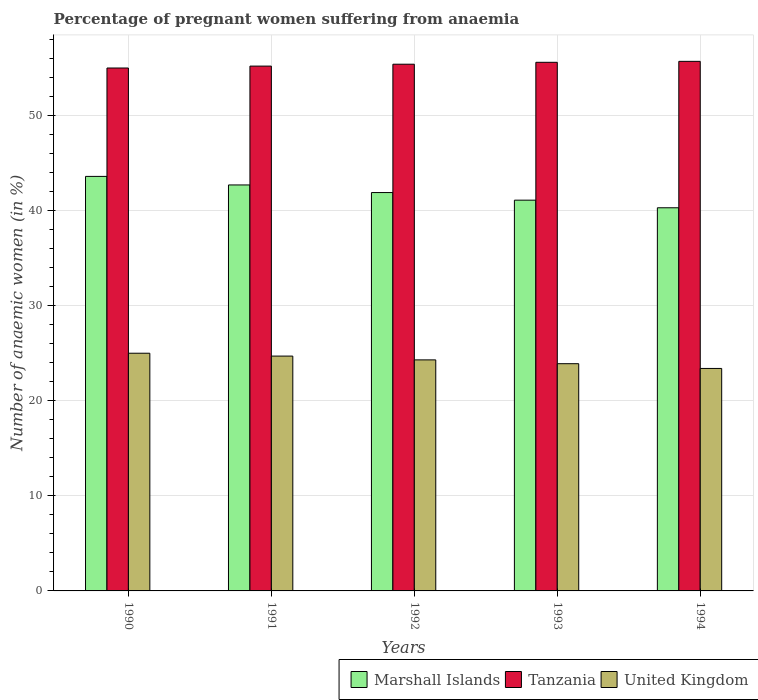How many different coloured bars are there?
Make the answer very short. 3. How many groups of bars are there?
Ensure brevity in your answer.  5. Are the number of bars per tick equal to the number of legend labels?
Keep it short and to the point. Yes. Are the number of bars on each tick of the X-axis equal?
Give a very brief answer. Yes. How many bars are there on the 5th tick from the left?
Provide a short and direct response. 3. How many bars are there on the 1st tick from the right?
Keep it short and to the point. 3. What is the label of the 5th group of bars from the left?
Ensure brevity in your answer.  1994. In how many cases, is the number of bars for a given year not equal to the number of legend labels?
Your answer should be very brief. 0. What is the number of anaemic women in United Kingdom in 1994?
Keep it short and to the point. 23.4. Across all years, what is the maximum number of anaemic women in Marshall Islands?
Your response must be concise. 43.6. Across all years, what is the minimum number of anaemic women in Marshall Islands?
Make the answer very short. 40.3. In which year was the number of anaemic women in United Kingdom minimum?
Provide a short and direct response. 1994. What is the total number of anaemic women in Tanzania in the graph?
Make the answer very short. 276.9. What is the difference between the number of anaemic women in Marshall Islands in 1990 and that in 1991?
Give a very brief answer. 0.9. What is the difference between the number of anaemic women in Tanzania in 1991 and the number of anaemic women in United Kingdom in 1990?
Ensure brevity in your answer.  30.2. What is the average number of anaemic women in Tanzania per year?
Your response must be concise. 55.38. What is the ratio of the number of anaemic women in United Kingdom in 1992 to that in 1994?
Offer a terse response. 1.04. Is the difference between the number of anaemic women in Marshall Islands in 1990 and 1991 greater than the difference between the number of anaemic women in United Kingdom in 1990 and 1991?
Provide a succinct answer. Yes. What is the difference between the highest and the second highest number of anaemic women in Tanzania?
Provide a short and direct response. 0.1. What is the difference between the highest and the lowest number of anaemic women in United Kingdom?
Your response must be concise. 1.6. In how many years, is the number of anaemic women in Marshall Islands greater than the average number of anaemic women in Marshall Islands taken over all years?
Offer a terse response. 2. What does the 2nd bar from the right in 1990 represents?
Give a very brief answer. Tanzania. Are all the bars in the graph horizontal?
Make the answer very short. No. What is the difference between two consecutive major ticks on the Y-axis?
Offer a very short reply. 10. Does the graph contain grids?
Give a very brief answer. Yes. Where does the legend appear in the graph?
Your response must be concise. Bottom right. How many legend labels are there?
Your answer should be very brief. 3. What is the title of the graph?
Provide a succinct answer. Percentage of pregnant women suffering from anaemia. What is the label or title of the Y-axis?
Your answer should be very brief. Number of anaemic women (in %). What is the Number of anaemic women (in %) in Marshall Islands in 1990?
Make the answer very short. 43.6. What is the Number of anaemic women (in %) of Tanzania in 1990?
Your answer should be compact. 55. What is the Number of anaemic women (in %) in Marshall Islands in 1991?
Your answer should be very brief. 42.7. What is the Number of anaemic women (in %) of Tanzania in 1991?
Provide a succinct answer. 55.2. What is the Number of anaemic women (in %) of United Kingdom in 1991?
Offer a very short reply. 24.7. What is the Number of anaemic women (in %) in Marshall Islands in 1992?
Make the answer very short. 41.9. What is the Number of anaemic women (in %) of Tanzania in 1992?
Provide a succinct answer. 55.4. What is the Number of anaemic women (in %) of United Kingdom in 1992?
Offer a terse response. 24.3. What is the Number of anaemic women (in %) of Marshall Islands in 1993?
Offer a terse response. 41.1. What is the Number of anaemic women (in %) of Tanzania in 1993?
Offer a very short reply. 55.6. What is the Number of anaemic women (in %) of United Kingdom in 1993?
Ensure brevity in your answer.  23.9. What is the Number of anaemic women (in %) of Marshall Islands in 1994?
Keep it short and to the point. 40.3. What is the Number of anaemic women (in %) in Tanzania in 1994?
Give a very brief answer. 55.7. What is the Number of anaemic women (in %) in United Kingdom in 1994?
Keep it short and to the point. 23.4. Across all years, what is the maximum Number of anaemic women (in %) in Marshall Islands?
Provide a short and direct response. 43.6. Across all years, what is the maximum Number of anaemic women (in %) of Tanzania?
Your answer should be very brief. 55.7. Across all years, what is the maximum Number of anaemic women (in %) in United Kingdom?
Keep it short and to the point. 25. Across all years, what is the minimum Number of anaemic women (in %) in Marshall Islands?
Keep it short and to the point. 40.3. Across all years, what is the minimum Number of anaemic women (in %) of United Kingdom?
Your answer should be compact. 23.4. What is the total Number of anaemic women (in %) in Marshall Islands in the graph?
Provide a succinct answer. 209.6. What is the total Number of anaemic women (in %) in Tanzania in the graph?
Provide a short and direct response. 276.9. What is the total Number of anaemic women (in %) in United Kingdom in the graph?
Make the answer very short. 121.3. What is the difference between the Number of anaemic women (in %) in Marshall Islands in 1990 and that in 1991?
Your answer should be compact. 0.9. What is the difference between the Number of anaemic women (in %) of United Kingdom in 1990 and that in 1991?
Your answer should be very brief. 0.3. What is the difference between the Number of anaemic women (in %) in Tanzania in 1990 and that in 1992?
Provide a succinct answer. -0.4. What is the difference between the Number of anaemic women (in %) in United Kingdom in 1990 and that in 1992?
Your answer should be compact. 0.7. What is the difference between the Number of anaemic women (in %) in Marshall Islands in 1990 and that in 1993?
Your answer should be compact. 2.5. What is the difference between the Number of anaemic women (in %) of Tanzania in 1990 and that in 1993?
Make the answer very short. -0.6. What is the difference between the Number of anaemic women (in %) of United Kingdom in 1990 and that in 1993?
Your answer should be compact. 1.1. What is the difference between the Number of anaemic women (in %) in Marshall Islands in 1990 and that in 1994?
Provide a short and direct response. 3.3. What is the difference between the Number of anaemic women (in %) in United Kingdom in 1990 and that in 1994?
Give a very brief answer. 1.6. What is the difference between the Number of anaemic women (in %) of United Kingdom in 1991 and that in 1992?
Provide a short and direct response. 0.4. What is the difference between the Number of anaemic women (in %) of Marshall Islands in 1991 and that in 1993?
Keep it short and to the point. 1.6. What is the difference between the Number of anaemic women (in %) in Tanzania in 1991 and that in 1993?
Your response must be concise. -0.4. What is the difference between the Number of anaemic women (in %) of Tanzania in 1991 and that in 1994?
Your answer should be very brief. -0.5. What is the difference between the Number of anaemic women (in %) in United Kingdom in 1991 and that in 1994?
Give a very brief answer. 1.3. What is the difference between the Number of anaemic women (in %) of Tanzania in 1992 and that in 1993?
Ensure brevity in your answer.  -0.2. What is the difference between the Number of anaemic women (in %) of United Kingdom in 1992 and that in 1993?
Make the answer very short. 0.4. What is the difference between the Number of anaemic women (in %) in Marshall Islands in 1992 and that in 1994?
Your answer should be very brief. 1.6. What is the difference between the Number of anaemic women (in %) of Marshall Islands in 1993 and that in 1994?
Offer a terse response. 0.8. What is the difference between the Number of anaemic women (in %) in Marshall Islands in 1990 and the Number of anaemic women (in %) in Tanzania in 1991?
Your answer should be very brief. -11.6. What is the difference between the Number of anaemic women (in %) of Marshall Islands in 1990 and the Number of anaemic women (in %) of United Kingdom in 1991?
Your answer should be compact. 18.9. What is the difference between the Number of anaemic women (in %) of Tanzania in 1990 and the Number of anaemic women (in %) of United Kingdom in 1991?
Offer a terse response. 30.3. What is the difference between the Number of anaemic women (in %) in Marshall Islands in 1990 and the Number of anaemic women (in %) in Tanzania in 1992?
Provide a short and direct response. -11.8. What is the difference between the Number of anaemic women (in %) in Marshall Islands in 1990 and the Number of anaemic women (in %) in United Kingdom in 1992?
Provide a short and direct response. 19.3. What is the difference between the Number of anaemic women (in %) of Tanzania in 1990 and the Number of anaemic women (in %) of United Kingdom in 1992?
Keep it short and to the point. 30.7. What is the difference between the Number of anaemic women (in %) of Marshall Islands in 1990 and the Number of anaemic women (in %) of Tanzania in 1993?
Provide a succinct answer. -12. What is the difference between the Number of anaemic women (in %) in Tanzania in 1990 and the Number of anaemic women (in %) in United Kingdom in 1993?
Keep it short and to the point. 31.1. What is the difference between the Number of anaemic women (in %) of Marshall Islands in 1990 and the Number of anaemic women (in %) of Tanzania in 1994?
Make the answer very short. -12.1. What is the difference between the Number of anaemic women (in %) in Marshall Islands in 1990 and the Number of anaemic women (in %) in United Kingdom in 1994?
Your answer should be compact. 20.2. What is the difference between the Number of anaemic women (in %) in Tanzania in 1990 and the Number of anaemic women (in %) in United Kingdom in 1994?
Keep it short and to the point. 31.6. What is the difference between the Number of anaemic women (in %) of Marshall Islands in 1991 and the Number of anaemic women (in %) of United Kingdom in 1992?
Give a very brief answer. 18.4. What is the difference between the Number of anaemic women (in %) of Tanzania in 1991 and the Number of anaemic women (in %) of United Kingdom in 1992?
Your response must be concise. 30.9. What is the difference between the Number of anaemic women (in %) in Tanzania in 1991 and the Number of anaemic women (in %) in United Kingdom in 1993?
Provide a short and direct response. 31.3. What is the difference between the Number of anaemic women (in %) of Marshall Islands in 1991 and the Number of anaemic women (in %) of United Kingdom in 1994?
Provide a succinct answer. 19.3. What is the difference between the Number of anaemic women (in %) in Tanzania in 1991 and the Number of anaemic women (in %) in United Kingdom in 1994?
Provide a short and direct response. 31.8. What is the difference between the Number of anaemic women (in %) in Marshall Islands in 1992 and the Number of anaemic women (in %) in Tanzania in 1993?
Keep it short and to the point. -13.7. What is the difference between the Number of anaemic women (in %) of Marshall Islands in 1992 and the Number of anaemic women (in %) of United Kingdom in 1993?
Offer a very short reply. 18. What is the difference between the Number of anaemic women (in %) in Tanzania in 1992 and the Number of anaemic women (in %) in United Kingdom in 1993?
Your answer should be very brief. 31.5. What is the difference between the Number of anaemic women (in %) in Marshall Islands in 1992 and the Number of anaemic women (in %) in Tanzania in 1994?
Provide a short and direct response. -13.8. What is the difference between the Number of anaemic women (in %) of Marshall Islands in 1992 and the Number of anaemic women (in %) of United Kingdom in 1994?
Your response must be concise. 18.5. What is the difference between the Number of anaemic women (in %) of Marshall Islands in 1993 and the Number of anaemic women (in %) of Tanzania in 1994?
Ensure brevity in your answer.  -14.6. What is the difference between the Number of anaemic women (in %) of Marshall Islands in 1993 and the Number of anaemic women (in %) of United Kingdom in 1994?
Give a very brief answer. 17.7. What is the difference between the Number of anaemic women (in %) in Tanzania in 1993 and the Number of anaemic women (in %) in United Kingdom in 1994?
Provide a short and direct response. 32.2. What is the average Number of anaemic women (in %) of Marshall Islands per year?
Provide a succinct answer. 41.92. What is the average Number of anaemic women (in %) in Tanzania per year?
Give a very brief answer. 55.38. What is the average Number of anaemic women (in %) in United Kingdom per year?
Keep it short and to the point. 24.26. In the year 1990, what is the difference between the Number of anaemic women (in %) in Marshall Islands and Number of anaemic women (in %) in United Kingdom?
Provide a succinct answer. 18.6. In the year 1991, what is the difference between the Number of anaemic women (in %) of Tanzania and Number of anaemic women (in %) of United Kingdom?
Offer a terse response. 30.5. In the year 1992, what is the difference between the Number of anaemic women (in %) of Marshall Islands and Number of anaemic women (in %) of Tanzania?
Make the answer very short. -13.5. In the year 1992, what is the difference between the Number of anaemic women (in %) of Tanzania and Number of anaemic women (in %) of United Kingdom?
Provide a succinct answer. 31.1. In the year 1993, what is the difference between the Number of anaemic women (in %) in Marshall Islands and Number of anaemic women (in %) in Tanzania?
Offer a very short reply. -14.5. In the year 1993, what is the difference between the Number of anaemic women (in %) of Marshall Islands and Number of anaemic women (in %) of United Kingdom?
Make the answer very short. 17.2. In the year 1993, what is the difference between the Number of anaemic women (in %) of Tanzania and Number of anaemic women (in %) of United Kingdom?
Keep it short and to the point. 31.7. In the year 1994, what is the difference between the Number of anaemic women (in %) in Marshall Islands and Number of anaemic women (in %) in Tanzania?
Ensure brevity in your answer.  -15.4. In the year 1994, what is the difference between the Number of anaemic women (in %) in Marshall Islands and Number of anaemic women (in %) in United Kingdom?
Give a very brief answer. 16.9. In the year 1994, what is the difference between the Number of anaemic women (in %) of Tanzania and Number of anaemic women (in %) of United Kingdom?
Keep it short and to the point. 32.3. What is the ratio of the Number of anaemic women (in %) in Marshall Islands in 1990 to that in 1991?
Your answer should be compact. 1.02. What is the ratio of the Number of anaemic women (in %) of Tanzania in 1990 to that in 1991?
Offer a very short reply. 1. What is the ratio of the Number of anaemic women (in %) in United Kingdom in 1990 to that in 1991?
Offer a very short reply. 1.01. What is the ratio of the Number of anaemic women (in %) in Marshall Islands in 1990 to that in 1992?
Your answer should be compact. 1.04. What is the ratio of the Number of anaemic women (in %) in United Kingdom in 1990 to that in 1992?
Keep it short and to the point. 1.03. What is the ratio of the Number of anaemic women (in %) in Marshall Islands in 1990 to that in 1993?
Give a very brief answer. 1.06. What is the ratio of the Number of anaemic women (in %) in Tanzania in 1990 to that in 1993?
Your answer should be very brief. 0.99. What is the ratio of the Number of anaemic women (in %) of United Kingdom in 1990 to that in 1993?
Your response must be concise. 1.05. What is the ratio of the Number of anaemic women (in %) of Marshall Islands in 1990 to that in 1994?
Your response must be concise. 1.08. What is the ratio of the Number of anaemic women (in %) of Tanzania in 1990 to that in 1994?
Ensure brevity in your answer.  0.99. What is the ratio of the Number of anaemic women (in %) of United Kingdom in 1990 to that in 1994?
Provide a short and direct response. 1.07. What is the ratio of the Number of anaemic women (in %) of Marshall Islands in 1991 to that in 1992?
Offer a very short reply. 1.02. What is the ratio of the Number of anaemic women (in %) of Tanzania in 1991 to that in 1992?
Make the answer very short. 1. What is the ratio of the Number of anaemic women (in %) of United Kingdom in 1991 to that in 1992?
Provide a succinct answer. 1.02. What is the ratio of the Number of anaemic women (in %) of Marshall Islands in 1991 to that in 1993?
Provide a succinct answer. 1.04. What is the ratio of the Number of anaemic women (in %) in United Kingdom in 1991 to that in 1993?
Keep it short and to the point. 1.03. What is the ratio of the Number of anaemic women (in %) of Marshall Islands in 1991 to that in 1994?
Keep it short and to the point. 1.06. What is the ratio of the Number of anaemic women (in %) in United Kingdom in 1991 to that in 1994?
Ensure brevity in your answer.  1.06. What is the ratio of the Number of anaemic women (in %) in Marshall Islands in 1992 to that in 1993?
Offer a terse response. 1.02. What is the ratio of the Number of anaemic women (in %) in United Kingdom in 1992 to that in 1993?
Offer a very short reply. 1.02. What is the ratio of the Number of anaemic women (in %) in Marshall Islands in 1992 to that in 1994?
Your answer should be compact. 1.04. What is the ratio of the Number of anaemic women (in %) of Tanzania in 1992 to that in 1994?
Make the answer very short. 0.99. What is the ratio of the Number of anaemic women (in %) of United Kingdom in 1992 to that in 1994?
Ensure brevity in your answer.  1.04. What is the ratio of the Number of anaemic women (in %) in Marshall Islands in 1993 to that in 1994?
Your answer should be compact. 1.02. What is the ratio of the Number of anaemic women (in %) in United Kingdom in 1993 to that in 1994?
Your answer should be compact. 1.02. 